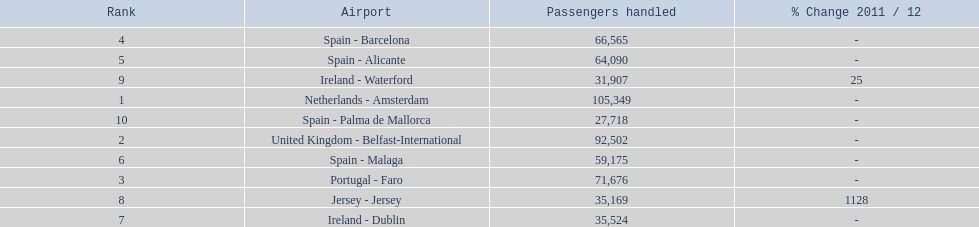Which airport has the least amount of passengers going through london southend airport? Spain - Palma de Mallorca. 